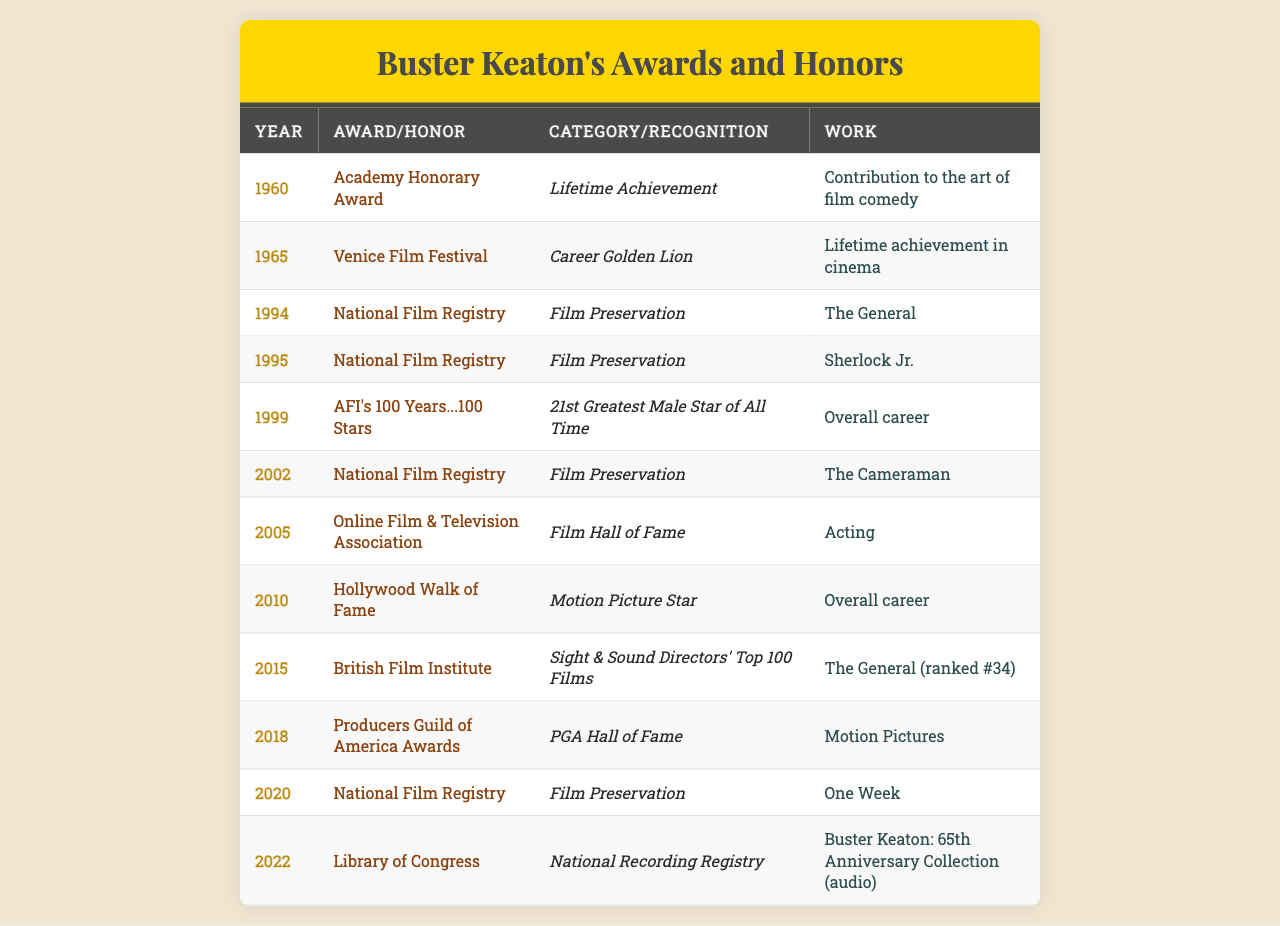What year did Buster Keaton receive the Academy Honorary Award? According to the table, Buster Keaton received the Academy Honorary Award in 1960.
Answer: 1960 How many awards or honors did Buster Keaton receive in the 1990s? The table lists three awards during the 1990s: two National Film Registries in 1994 and 1995, and none in 1990. This sums up to three awards during that decade.
Answer: 3 Which award recognizes Buster Keaton's contribution to film preservation? The National Film Registry recognizes Buster Keaton's films for preservation, and he received this honor in 1994, 1995, and 2002.
Answer: National Film Registry Did Buster Keaton receive the Venice Film Festival Career Golden Lion before or after the 1994 National Film Registry recognition of "The General"? The Venice Film Festival award was given to him in 1965, which is before the 1994 National Film Registry recognition of "The General".
Answer: Before What is the total number of unique awards listed in the table that honor Buster Keaton's lifetime achievements? The table lists two awards that specifically recognize his lifetime achievements: the Academy Honorary Award in 1960 and the Venice Film Festival Career Golden Lion in 1965. This totals to two unique lifetime achievement awards.
Answer: 2 Which film was recognized in the National Film Registry the latest? The latest recognition in the National Film Registry is for "One Week" received in 2020.
Answer: One Week Was "Sherlock Jr." recognized in the National Film Registry more than once? No, "Sherlock Jr." was recognized in the National Film Registry only once, in 1995.
Answer: No How many of the honors listed in the table were received posthumously? The only recognized posthumous honors in the table are today's entries from 2020 and 2022. Therefore, there are two posthumous recognitions.
Answer: 2 Which work associated with Buster Keaton is ranked in the British Film Institute's Sight & Sound Directors' Top 100 Films? "The General" is ranked #34 in the British Film Institute's Sight & Sound Directors' Top 100 Films received in 2015.
Answer: The General What is the most recent award Buster Keaton received, and in what year? The most recent award listed in the table is from the Library of Congress for the "Buster Keaton: 65th Anniversary Collection (audio)" awarded in 2022.
Answer: 2022 Did any of the awards honor more than one work? No, all awards listed specifically recognize one individual work, not multiple works.
Answer: No 